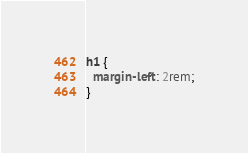<code> <loc_0><loc_0><loc_500><loc_500><_CSS_>h1 {
  margin-left: 2rem;
}
</code> 